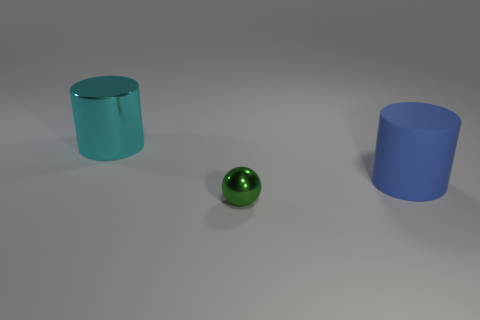Add 3 large metal things. How many objects exist? 6 Subtract all balls. How many objects are left? 2 Subtract all green things. Subtract all blue metallic spheres. How many objects are left? 2 Add 3 metallic objects. How many metallic objects are left? 5 Add 2 green metallic objects. How many green metallic objects exist? 3 Subtract 0 gray blocks. How many objects are left? 3 